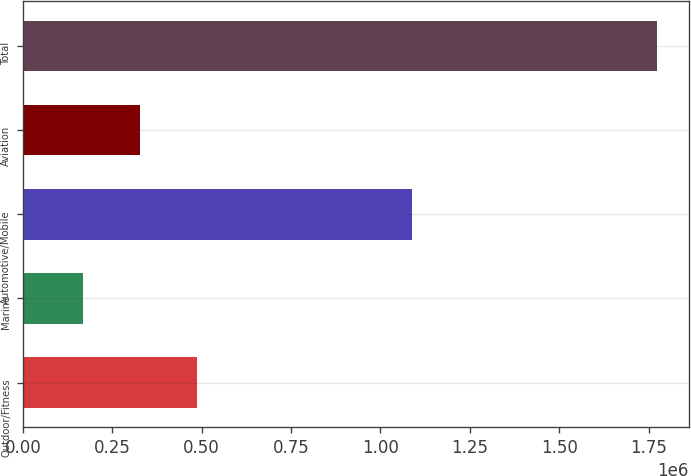<chart> <loc_0><loc_0><loc_500><loc_500><bar_chart><fcel>Outdoor/Fitness<fcel>Marine<fcel>Automotive/Mobile<fcel>Aviation<fcel>Total<nl><fcel>488111<fcel>166639<fcel>1.08909e+06<fcel>327375<fcel>1.774e+06<nl></chart> 